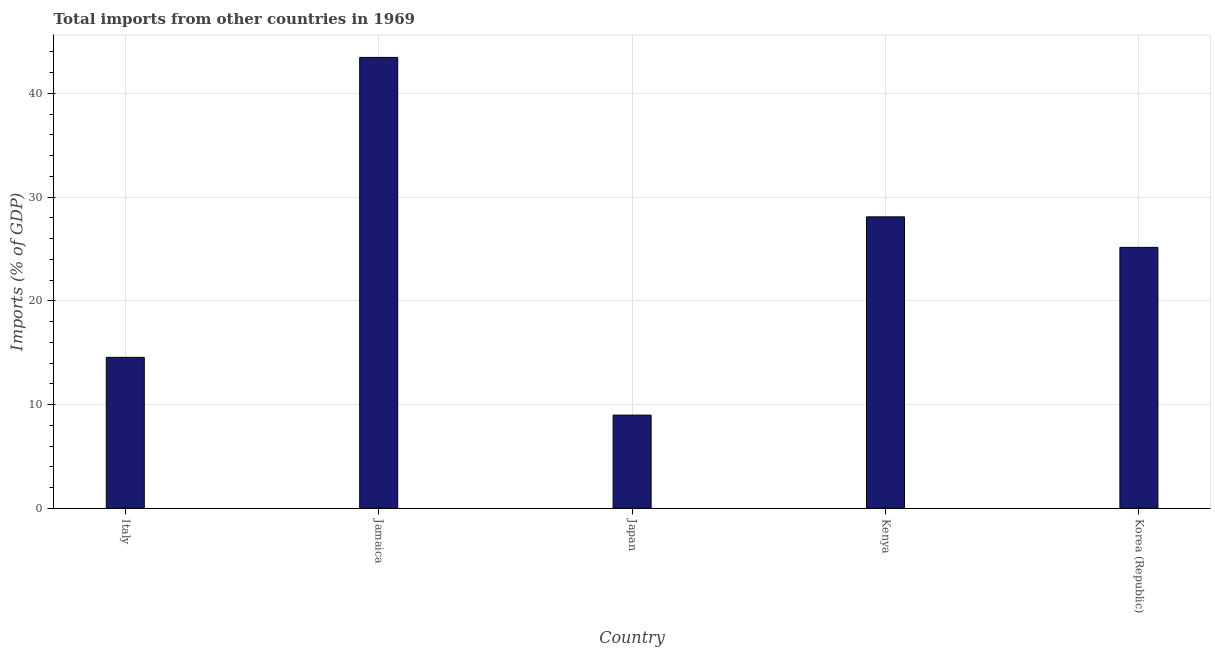Does the graph contain any zero values?
Your answer should be very brief. No. Does the graph contain grids?
Ensure brevity in your answer.  Yes. What is the title of the graph?
Your answer should be compact. Total imports from other countries in 1969. What is the label or title of the X-axis?
Your answer should be compact. Country. What is the label or title of the Y-axis?
Your answer should be very brief. Imports (% of GDP). What is the total imports in Korea (Republic)?
Provide a short and direct response. 25.15. Across all countries, what is the maximum total imports?
Make the answer very short. 43.46. Across all countries, what is the minimum total imports?
Your response must be concise. 8.98. In which country was the total imports maximum?
Your answer should be very brief. Jamaica. What is the sum of the total imports?
Your response must be concise. 120.22. What is the difference between the total imports in Japan and Kenya?
Offer a very short reply. -19.11. What is the average total imports per country?
Offer a terse response. 24.04. What is the median total imports?
Offer a terse response. 25.15. In how many countries, is the total imports greater than 14 %?
Keep it short and to the point. 4. What is the ratio of the total imports in Japan to that in Kenya?
Provide a succinct answer. 0.32. Is the difference between the total imports in Kenya and Korea (Republic) greater than the difference between any two countries?
Your response must be concise. No. What is the difference between the highest and the second highest total imports?
Provide a short and direct response. 15.37. Is the sum of the total imports in Jamaica and Japan greater than the maximum total imports across all countries?
Offer a very short reply. Yes. What is the difference between the highest and the lowest total imports?
Make the answer very short. 34.48. In how many countries, is the total imports greater than the average total imports taken over all countries?
Your answer should be compact. 3. How many bars are there?
Provide a succinct answer. 5. Are all the bars in the graph horizontal?
Offer a very short reply. No. How many countries are there in the graph?
Make the answer very short. 5. What is the difference between two consecutive major ticks on the Y-axis?
Provide a short and direct response. 10. Are the values on the major ticks of Y-axis written in scientific E-notation?
Offer a terse response. No. What is the Imports (% of GDP) in Italy?
Offer a terse response. 14.55. What is the Imports (% of GDP) of Jamaica?
Provide a short and direct response. 43.46. What is the Imports (% of GDP) of Japan?
Keep it short and to the point. 8.98. What is the Imports (% of GDP) of Kenya?
Provide a succinct answer. 28.09. What is the Imports (% of GDP) in Korea (Republic)?
Your response must be concise. 25.15. What is the difference between the Imports (% of GDP) in Italy and Jamaica?
Give a very brief answer. -28.91. What is the difference between the Imports (% of GDP) in Italy and Japan?
Your answer should be very brief. 5.57. What is the difference between the Imports (% of GDP) in Italy and Kenya?
Your answer should be compact. -13.54. What is the difference between the Imports (% of GDP) in Italy and Korea (Republic)?
Offer a terse response. -10.6. What is the difference between the Imports (% of GDP) in Jamaica and Japan?
Your answer should be very brief. 34.48. What is the difference between the Imports (% of GDP) in Jamaica and Kenya?
Your answer should be very brief. 15.37. What is the difference between the Imports (% of GDP) in Jamaica and Korea (Republic)?
Your answer should be very brief. 18.31. What is the difference between the Imports (% of GDP) in Japan and Kenya?
Ensure brevity in your answer.  -19.11. What is the difference between the Imports (% of GDP) in Japan and Korea (Republic)?
Offer a very short reply. -16.17. What is the difference between the Imports (% of GDP) in Kenya and Korea (Republic)?
Make the answer very short. 2.94. What is the ratio of the Imports (% of GDP) in Italy to that in Jamaica?
Provide a succinct answer. 0.34. What is the ratio of the Imports (% of GDP) in Italy to that in Japan?
Make the answer very short. 1.62. What is the ratio of the Imports (% of GDP) in Italy to that in Kenya?
Your response must be concise. 0.52. What is the ratio of the Imports (% of GDP) in Italy to that in Korea (Republic)?
Your response must be concise. 0.58. What is the ratio of the Imports (% of GDP) in Jamaica to that in Japan?
Offer a terse response. 4.84. What is the ratio of the Imports (% of GDP) in Jamaica to that in Kenya?
Ensure brevity in your answer.  1.55. What is the ratio of the Imports (% of GDP) in Jamaica to that in Korea (Republic)?
Make the answer very short. 1.73. What is the ratio of the Imports (% of GDP) in Japan to that in Kenya?
Your answer should be very brief. 0.32. What is the ratio of the Imports (% of GDP) in Japan to that in Korea (Republic)?
Offer a very short reply. 0.36. What is the ratio of the Imports (% of GDP) in Kenya to that in Korea (Republic)?
Offer a terse response. 1.12. 